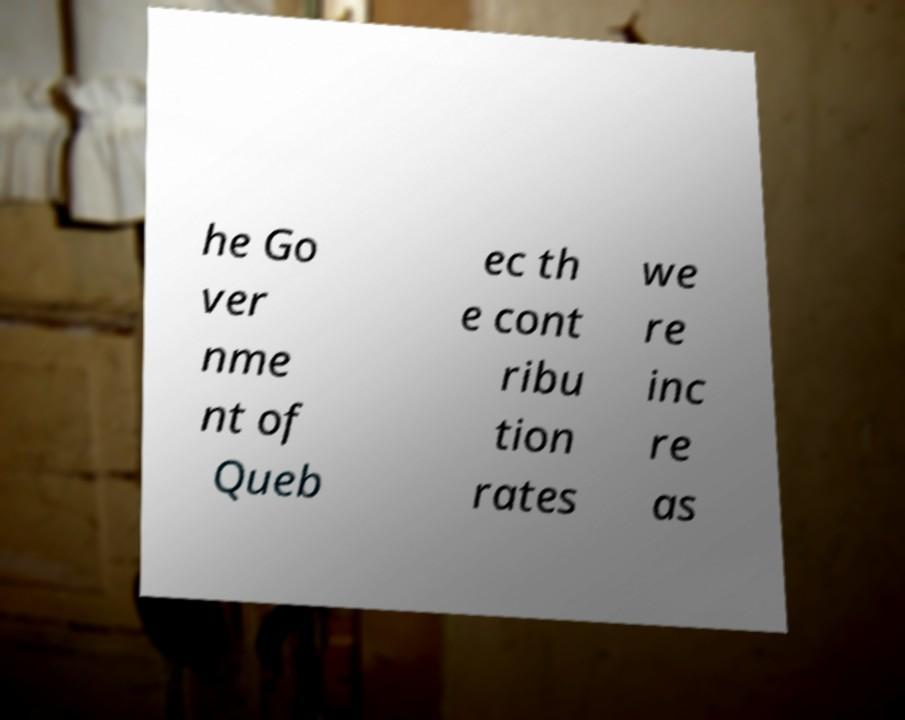There's text embedded in this image that I need extracted. Can you transcribe it verbatim? he Go ver nme nt of Queb ec th e cont ribu tion rates we re inc re as 